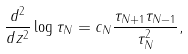<formula> <loc_0><loc_0><loc_500><loc_500>\frac { d ^ { 2 } } { d z ^ { 2 } } \log \tau _ { N } = c _ { N } \frac { \tau _ { N + 1 } \tau _ { N - 1 } } { \tau _ { N } ^ { 2 } } ,</formula> 